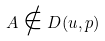<formula> <loc_0><loc_0><loc_500><loc_500>A \notin D ( u , p )</formula> 